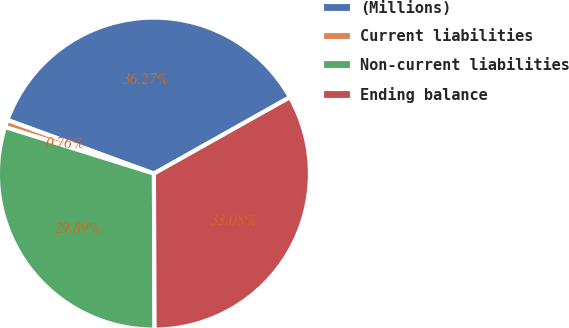Convert chart to OTSL. <chart><loc_0><loc_0><loc_500><loc_500><pie_chart><fcel>(Millions)<fcel>Current liabilities<fcel>Non-current liabilities<fcel>Ending balance<nl><fcel>36.27%<fcel>0.76%<fcel>29.89%<fcel>33.08%<nl></chart> 